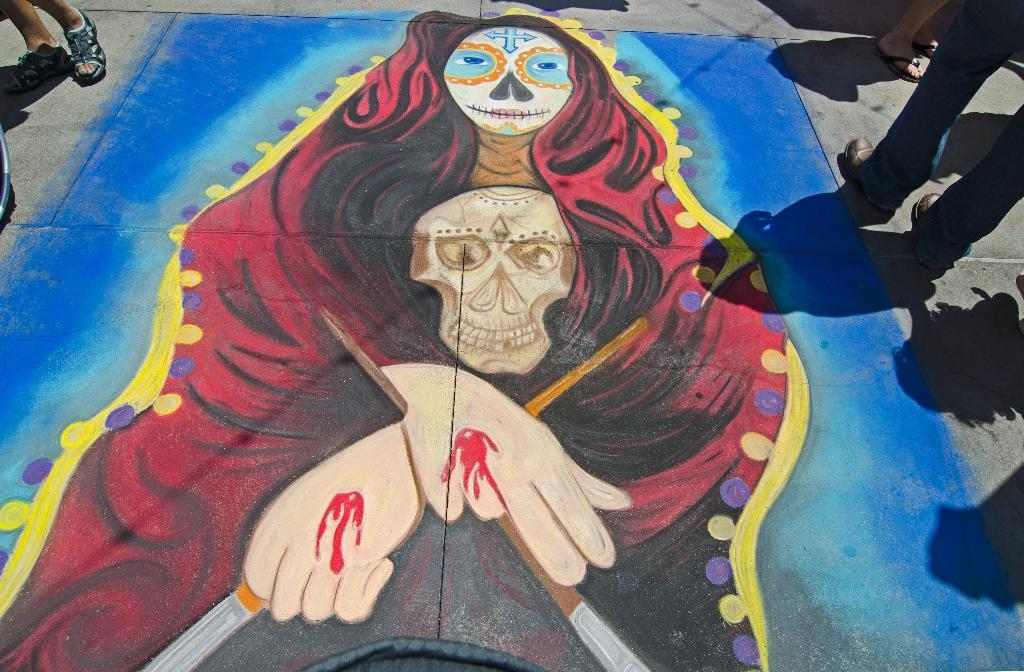What can be seen in the image involving people? There are people standing in the image. Where are the people standing? The people are standing on the floor. What is another object or feature present in the image? There is a painting in the image. What is depicted in the painting? The painting depicts a woman and a skull. What type of string is being used to create a selection of thrills in the image? There is no string or selection of thrills present in the image. 